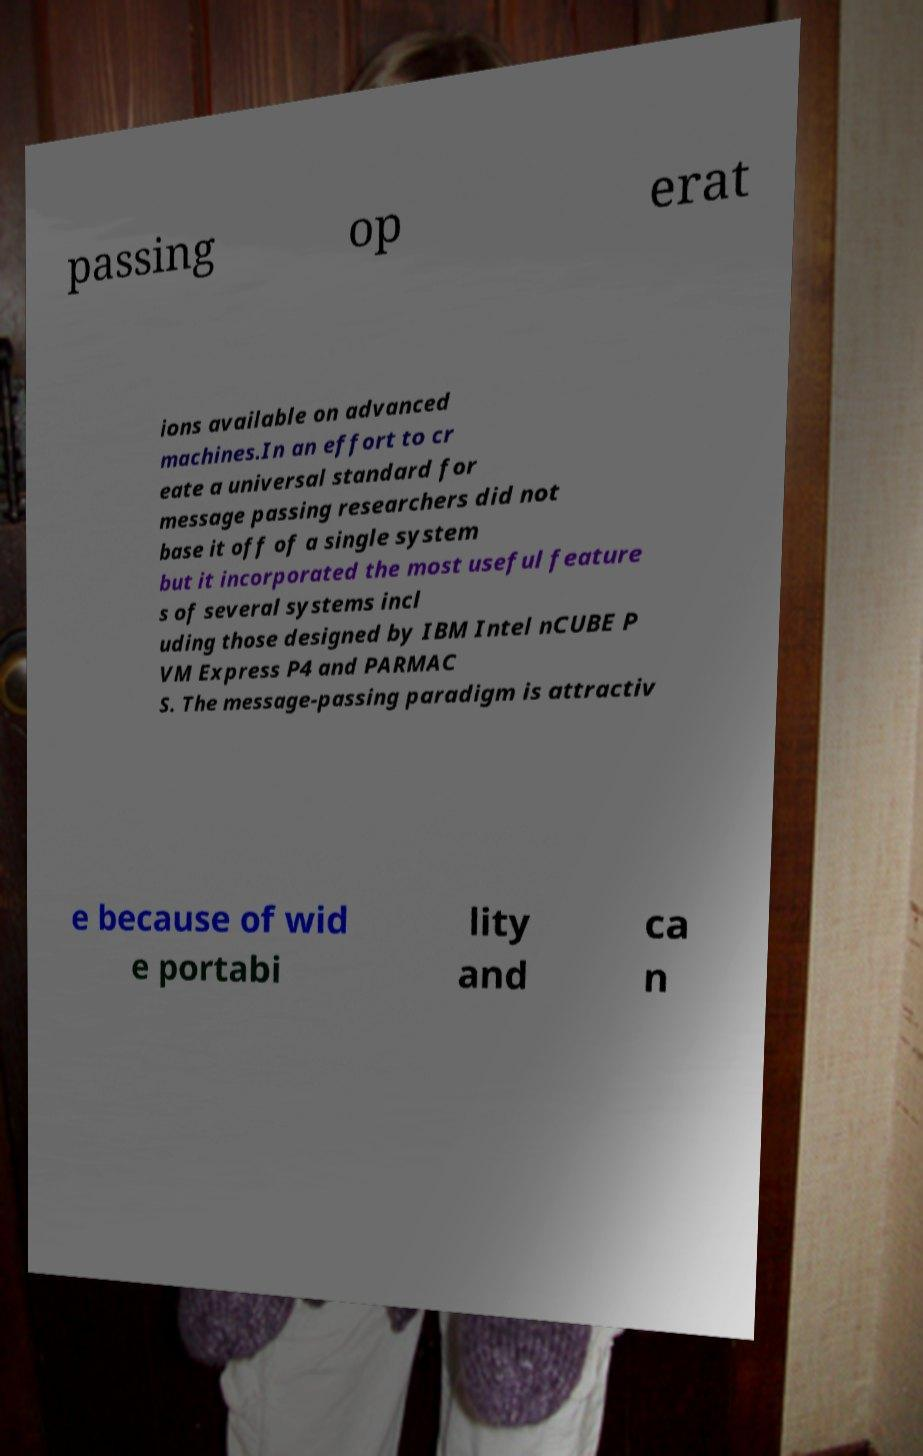Please identify and transcribe the text found in this image. passing op erat ions available on advanced machines.In an effort to cr eate a universal standard for message passing researchers did not base it off of a single system but it incorporated the most useful feature s of several systems incl uding those designed by IBM Intel nCUBE P VM Express P4 and PARMAC S. The message-passing paradigm is attractiv e because of wid e portabi lity and ca n 